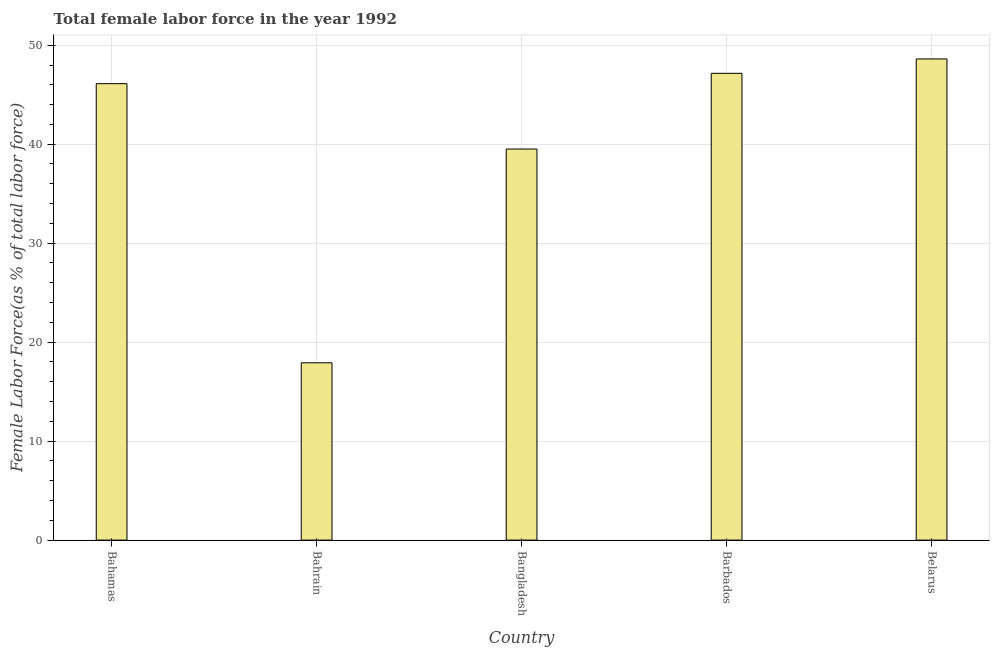What is the title of the graph?
Give a very brief answer. Total female labor force in the year 1992. What is the label or title of the Y-axis?
Give a very brief answer. Female Labor Force(as % of total labor force). What is the total female labor force in Belarus?
Offer a terse response. 48.61. Across all countries, what is the maximum total female labor force?
Offer a very short reply. 48.61. Across all countries, what is the minimum total female labor force?
Give a very brief answer. 17.92. In which country was the total female labor force maximum?
Your answer should be compact. Belarus. In which country was the total female labor force minimum?
Keep it short and to the point. Bahrain. What is the sum of the total female labor force?
Provide a succinct answer. 199.32. What is the difference between the total female labor force in Bangladesh and Barbados?
Offer a terse response. -7.65. What is the average total female labor force per country?
Provide a succinct answer. 39.86. What is the median total female labor force?
Your answer should be compact. 46.12. What is the ratio of the total female labor force in Bahrain to that in Belarus?
Give a very brief answer. 0.37. Is the total female labor force in Bahamas less than that in Bahrain?
Provide a succinct answer. No. Is the difference between the total female labor force in Barbados and Belarus greater than the difference between any two countries?
Offer a very short reply. No. What is the difference between the highest and the second highest total female labor force?
Offer a very short reply. 1.45. What is the difference between the highest and the lowest total female labor force?
Keep it short and to the point. 30.7. In how many countries, is the total female labor force greater than the average total female labor force taken over all countries?
Ensure brevity in your answer.  3. How many countries are there in the graph?
Make the answer very short. 5. What is the difference between two consecutive major ticks on the Y-axis?
Give a very brief answer. 10. Are the values on the major ticks of Y-axis written in scientific E-notation?
Your answer should be very brief. No. What is the Female Labor Force(as % of total labor force) of Bahamas?
Keep it short and to the point. 46.12. What is the Female Labor Force(as % of total labor force) in Bahrain?
Your response must be concise. 17.92. What is the Female Labor Force(as % of total labor force) in Bangladesh?
Provide a short and direct response. 39.51. What is the Female Labor Force(as % of total labor force) of Barbados?
Keep it short and to the point. 47.16. What is the Female Labor Force(as % of total labor force) of Belarus?
Your answer should be very brief. 48.61. What is the difference between the Female Labor Force(as % of total labor force) in Bahamas and Bahrain?
Provide a short and direct response. 28.2. What is the difference between the Female Labor Force(as % of total labor force) in Bahamas and Bangladesh?
Ensure brevity in your answer.  6.6. What is the difference between the Female Labor Force(as % of total labor force) in Bahamas and Barbados?
Make the answer very short. -1.05. What is the difference between the Female Labor Force(as % of total labor force) in Bahamas and Belarus?
Your answer should be compact. -2.5. What is the difference between the Female Labor Force(as % of total labor force) in Bahrain and Bangladesh?
Your answer should be compact. -21.6. What is the difference between the Female Labor Force(as % of total labor force) in Bahrain and Barbados?
Make the answer very short. -29.25. What is the difference between the Female Labor Force(as % of total labor force) in Bahrain and Belarus?
Make the answer very short. -30.7. What is the difference between the Female Labor Force(as % of total labor force) in Bangladesh and Barbados?
Make the answer very short. -7.65. What is the difference between the Female Labor Force(as % of total labor force) in Bangladesh and Belarus?
Provide a short and direct response. -9.1. What is the difference between the Female Labor Force(as % of total labor force) in Barbados and Belarus?
Make the answer very short. -1.45. What is the ratio of the Female Labor Force(as % of total labor force) in Bahamas to that in Bahrain?
Keep it short and to the point. 2.57. What is the ratio of the Female Labor Force(as % of total labor force) in Bahamas to that in Bangladesh?
Make the answer very short. 1.17. What is the ratio of the Female Labor Force(as % of total labor force) in Bahamas to that in Barbados?
Your response must be concise. 0.98. What is the ratio of the Female Labor Force(as % of total labor force) in Bahamas to that in Belarus?
Ensure brevity in your answer.  0.95. What is the ratio of the Female Labor Force(as % of total labor force) in Bahrain to that in Bangladesh?
Offer a terse response. 0.45. What is the ratio of the Female Labor Force(as % of total labor force) in Bahrain to that in Barbados?
Give a very brief answer. 0.38. What is the ratio of the Female Labor Force(as % of total labor force) in Bahrain to that in Belarus?
Give a very brief answer. 0.37. What is the ratio of the Female Labor Force(as % of total labor force) in Bangladesh to that in Barbados?
Your response must be concise. 0.84. What is the ratio of the Female Labor Force(as % of total labor force) in Bangladesh to that in Belarus?
Offer a very short reply. 0.81. 